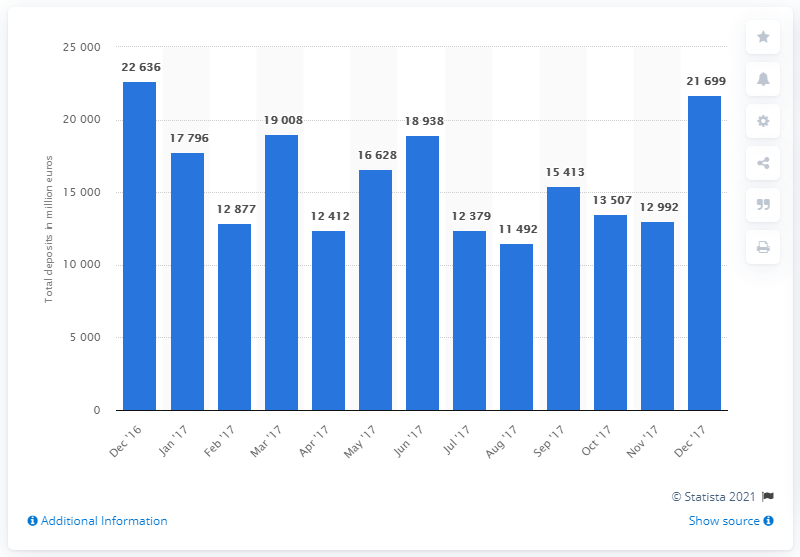Indicate a few pertinent items in this graphic. In December 2017, the total amount of savings accounts in the Netherlands was 21,699. 